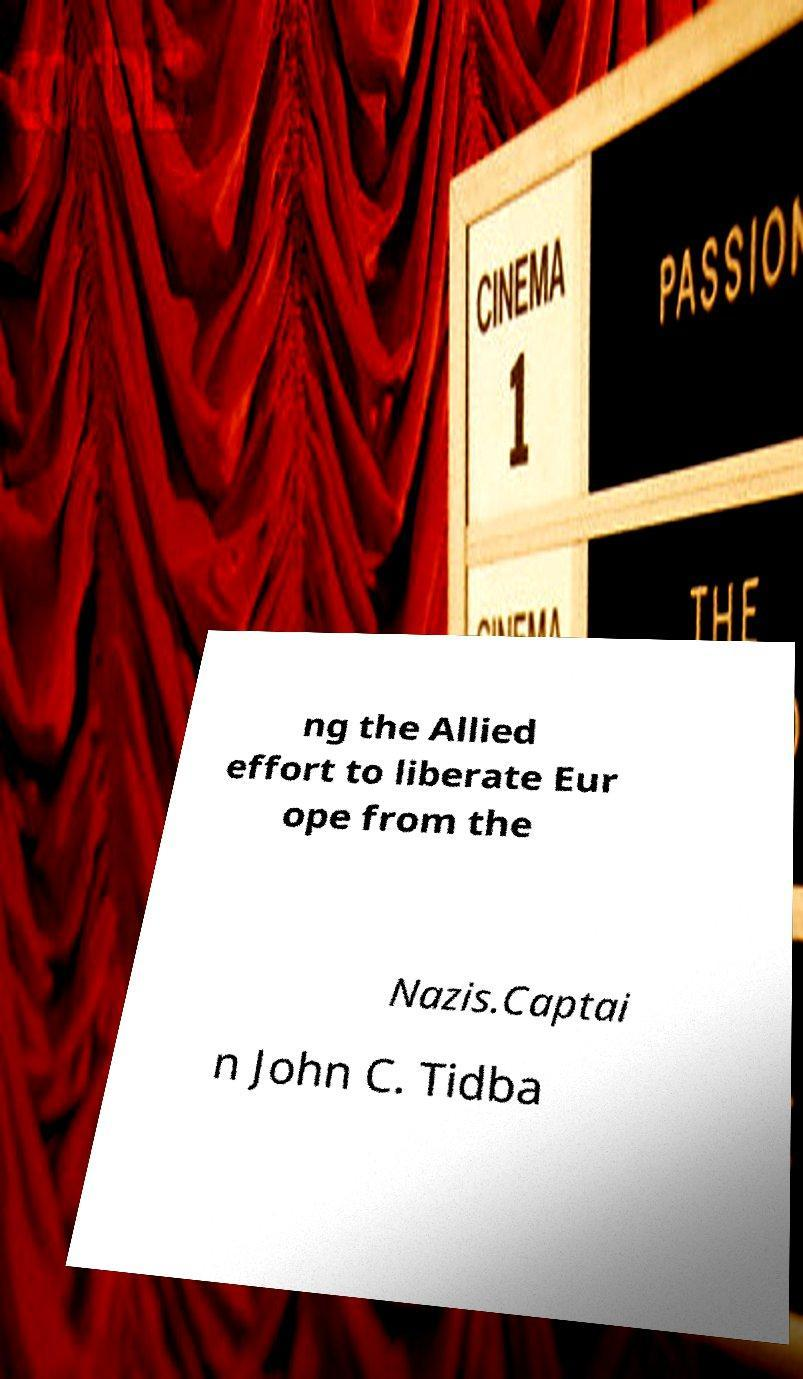What messages or text are displayed in this image? I need them in a readable, typed format. ng the Allied effort to liberate Eur ope from the Nazis.Captai n John C. Tidba 